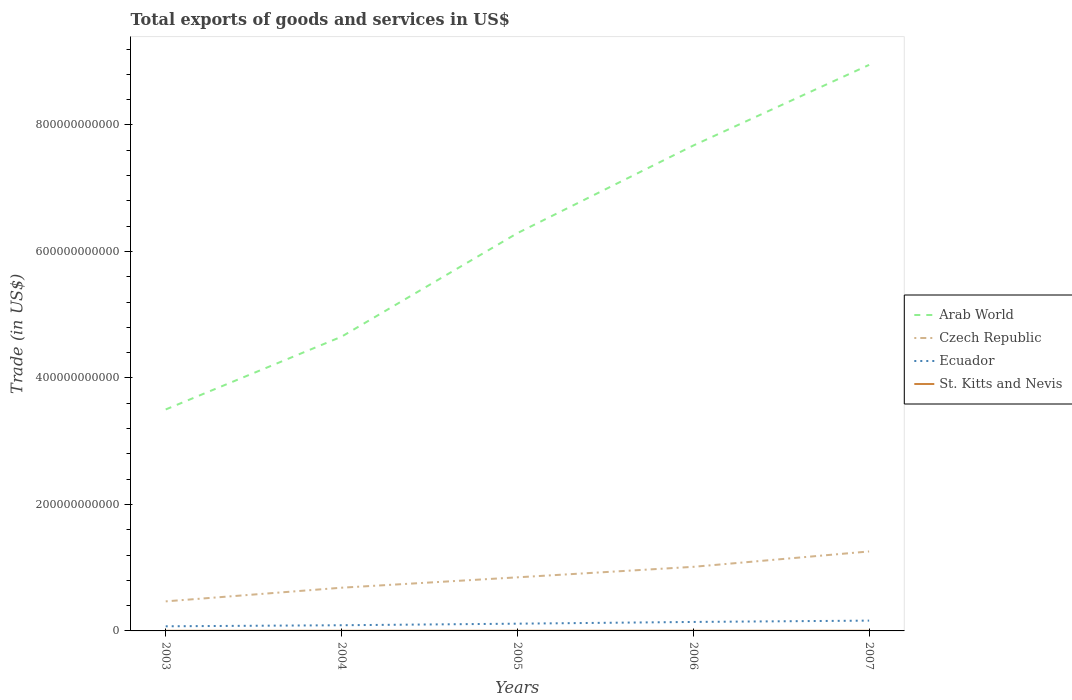Is the number of lines equal to the number of legend labels?
Ensure brevity in your answer.  Yes. Across all years, what is the maximum total exports of goods and services in Arab World?
Your answer should be very brief. 3.50e+11. What is the total total exports of goods and services in Arab World in the graph?
Offer a very short reply. -1.64e+11. What is the difference between the highest and the second highest total exports of goods and services in Ecuador?
Make the answer very short. 8.96e+09. How many lines are there?
Give a very brief answer. 4. How many years are there in the graph?
Your answer should be compact. 5. What is the difference between two consecutive major ticks on the Y-axis?
Your answer should be compact. 2.00e+11. Does the graph contain any zero values?
Your answer should be compact. No. Does the graph contain grids?
Your answer should be compact. No. Where does the legend appear in the graph?
Provide a short and direct response. Center right. What is the title of the graph?
Your answer should be compact. Total exports of goods and services in US$. What is the label or title of the Y-axis?
Give a very brief answer. Trade (in US$). What is the Trade (in US$) of Arab World in 2003?
Provide a short and direct response. 3.50e+11. What is the Trade (in US$) in Czech Republic in 2003?
Offer a very short reply. 4.67e+1. What is the Trade (in US$) in Ecuador in 2003?
Your response must be concise. 7.33e+09. What is the Trade (in US$) of St. Kitts and Nevis in 2003?
Give a very brief answer. 1.65e+08. What is the Trade (in US$) of Arab World in 2004?
Offer a very short reply. 4.65e+11. What is the Trade (in US$) in Czech Republic in 2004?
Give a very brief answer. 6.83e+1. What is the Trade (in US$) of Ecuador in 2004?
Offer a terse response. 8.98e+09. What is the Trade (in US$) of St. Kitts and Nevis in 2004?
Your answer should be very brief. 1.94e+08. What is the Trade (in US$) in Arab World in 2005?
Your answer should be compact. 6.29e+11. What is the Trade (in US$) of Czech Republic in 2005?
Your response must be concise. 8.47e+1. What is the Trade (in US$) of Ecuador in 2005?
Your response must be concise. 1.15e+1. What is the Trade (in US$) in St. Kitts and Nevis in 2005?
Your answer should be very brief. 2.27e+08. What is the Trade (in US$) in Arab World in 2006?
Give a very brief answer. 7.67e+11. What is the Trade (in US$) of Czech Republic in 2006?
Offer a very short reply. 1.01e+11. What is the Trade (in US$) of Ecuador in 2006?
Keep it short and to the point. 1.42e+1. What is the Trade (in US$) of St. Kitts and Nevis in 2006?
Keep it short and to the point. 2.36e+08. What is the Trade (in US$) of Arab World in 2007?
Make the answer very short. 8.95e+11. What is the Trade (in US$) of Czech Republic in 2007?
Keep it short and to the point. 1.26e+11. What is the Trade (in US$) of Ecuador in 2007?
Offer a very short reply. 1.63e+1. What is the Trade (in US$) in St. Kitts and Nevis in 2007?
Ensure brevity in your answer.  2.33e+08. Across all years, what is the maximum Trade (in US$) of Arab World?
Provide a short and direct response. 8.95e+11. Across all years, what is the maximum Trade (in US$) of Czech Republic?
Give a very brief answer. 1.26e+11. Across all years, what is the maximum Trade (in US$) of Ecuador?
Make the answer very short. 1.63e+1. Across all years, what is the maximum Trade (in US$) in St. Kitts and Nevis?
Offer a terse response. 2.36e+08. Across all years, what is the minimum Trade (in US$) of Arab World?
Make the answer very short. 3.50e+11. Across all years, what is the minimum Trade (in US$) of Czech Republic?
Offer a very short reply. 4.67e+1. Across all years, what is the minimum Trade (in US$) in Ecuador?
Offer a very short reply. 7.33e+09. Across all years, what is the minimum Trade (in US$) of St. Kitts and Nevis?
Your response must be concise. 1.65e+08. What is the total Trade (in US$) in Arab World in the graph?
Offer a terse response. 3.11e+12. What is the total Trade (in US$) in Czech Republic in the graph?
Provide a succinct answer. 4.27e+11. What is the total Trade (in US$) of Ecuador in the graph?
Make the answer very short. 5.83e+1. What is the total Trade (in US$) in St. Kitts and Nevis in the graph?
Offer a very short reply. 1.05e+09. What is the difference between the Trade (in US$) in Arab World in 2003 and that in 2004?
Provide a short and direct response. -1.15e+11. What is the difference between the Trade (in US$) of Czech Republic in 2003 and that in 2004?
Ensure brevity in your answer.  -2.16e+1. What is the difference between the Trade (in US$) in Ecuador in 2003 and that in 2004?
Give a very brief answer. -1.66e+09. What is the difference between the Trade (in US$) of St. Kitts and Nevis in 2003 and that in 2004?
Offer a terse response. -2.86e+07. What is the difference between the Trade (in US$) in Arab World in 2003 and that in 2005?
Keep it short and to the point. -2.79e+11. What is the difference between the Trade (in US$) in Czech Republic in 2003 and that in 2005?
Provide a short and direct response. -3.80e+1. What is the difference between the Trade (in US$) of Ecuador in 2003 and that in 2005?
Ensure brevity in your answer.  -4.13e+09. What is the difference between the Trade (in US$) of St. Kitts and Nevis in 2003 and that in 2005?
Your answer should be very brief. -6.13e+07. What is the difference between the Trade (in US$) in Arab World in 2003 and that in 2006?
Provide a succinct answer. -4.17e+11. What is the difference between the Trade (in US$) of Czech Republic in 2003 and that in 2006?
Ensure brevity in your answer.  -5.46e+1. What is the difference between the Trade (in US$) of Ecuador in 2003 and that in 2006?
Your answer should be compact. -6.87e+09. What is the difference between the Trade (in US$) in St. Kitts and Nevis in 2003 and that in 2006?
Offer a terse response. -7.04e+07. What is the difference between the Trade (in US$) of Arab World in 2003 and that in 2007?
Ensure brevity in your answer.  -5.45e+11. What is the difference between the Trade (in US$) of Czech Republic in 2003 and that in 2007?
Make the answer very short. -7.89e+1. What is the difference between the Trade (in US$) in Ecuador in 2003 and that in 2007?
Give a very brief answer. -8.96e+09. What is the difference between the Trade (in US$) of St. Kitts and Nevis in 2003 and that in 2007?
Offer a very short reply. -6.77e+07. What is the difference between the Trade (in US$) in Arab World in 2004 and that in 2005?
Provide a succinct answer. -1.64e+11. What is the difference between the Trade (in US$) of Czech Republic in 2004 and that in 2005?
Provide a succinct answer. -1.64e+1. What is the difference between the Trade (in US$) in Ecuador in 2004 and that in 2005?
Offer a terse response. -2.48e+09. What is the difference between the Trade (in US$) in St. Kitts and Nevis in 2004 and that in 2005?
Offer a terse response. -3.27e+07. What is the difference between the Trade (in US$) of Arab World in 2004 and that in 2006?
Provide a short and direct response. -3.02e+11. What is the difference between the Trade (in US$) in Czech Republic in 2004 and that in 2006?
Provide a succinct answer. -3.30e+1. What is the difference between the Trade (in US$) of Ecuador in 2004 and that in 2006?
Ensure brevity in your answer.  -5.21e+09. What is the difference between the Trade (in US$) in St. Kitts and Nevis in 2004 and that in 2006?
Provide a short and direct response. -4.18e+07. What is the difference between the Trade (in US$) of Arab World in 2004 and that in 2007?
Give a very brief answer. -4.30e+11. What is the difference between the Trade (in US$) in Czech Republic in 2004 and that in 2007?
Your response must be concise. -5.73e+1. What is the difference between the Trade (in US$) of Ecuador in 2004 and that in 2007?
Offer a terse response. -7.30e+09. What is the difference between the Trade (in US$) of St. Kitts and Nevis in 2004 and that in 2007?
Give a very brief answer. -3.91e+07. What is the difference between the Trade (in US$) in Arab World in 2005 and that in 2006?
Give a very brief answer. -1.39e+11. What is the difference between the Trade (in US$) of Czech Republic in 2005 and that in 2006?
Offer a terse response. -1.66e+1. What is the difference between the Trade (in US$) of Ecuador in 2005 and that in 2006?
Provide a short and direct response. -2.73e+09. What is the difference between the Trade (in US$) of St. Kitts and Nevis in 2005 and that in 2006?
Your response must be concise. -9.05e+06. What is the difference between the Trade (in US$) of Arab World in 2005 and that in 2007?
Offer a very short reply. -2.66e+11. What is the difference between the Trade (in US$) in Czech Republic in 2005 and that in 2007?
Provide a succinct answer. -4.09e+1. What is the difference between the Trade (in US$) in Ecuador in 2005 and that in 2007?
Give a very brief answer. -4.82e+09. What is the difference between the Trade (in US$) of St. Kitts and Nevis in 2005 and that in 2007?
Keep it short and to the point. -6.36e+06. What is the difference between the Trade (in US$) in Arab World in 2006 and that in 2007?
Provide a short and direct response. -1.28e+11. What is the difference between the Trade (in US$) of Czech Republic in 2006 and that in 2007?
Your answer should be very brief. -2.43e+1. What is the difference between the Trade (in US$) in Ecuador in 2006 and that in 2007?
Your answer should be very brief. -2.09e+09. What is the difference between the Trade (in US$) in St. Kitts and Nevis in 2006 and that in 2007?
Make the answer very short. 2.69e+06. What is the difference between the Trade (in US$) of Arab World in 2003 and the Trade (in US$) of Czech Republic in 2004?
Make the answer very short. 2.82e+11. What is the difference between the Trade (in US$) in Arab World in 2003 and the Trade (in US$) in Ecuador in 2004?
Your answer should be very brief. 3.41e+11. What is the difference between the Trade (in US$) in Arab World in 2003 and the Trade (in US$) in St. Kitts and Nevis in 2004?
Provide a succinct answer. 3.50e+11. What is the difference between the Trade (in US$) of Czech Republic in 2003 and the Trade (in US$) of Ecuador in 2004?
Offer a very short reply. 3.77e+1. What is the difference between the Trade (in US$) in Czech Republic in 2003 and the Trade (in US$) in St. Kitts and Nevis in 2004?
Your answer should be very brief. 4.65e+1. What is the difference between the Trade (in US$) in Ecuador in 2003 and the Trade (in US$) in St. Kitts and Nevis in 2004?
Your answer should be compact. 7.14e+09. What is the difference between the Trade (in US$) of Arab World in 2003 and the Trade (in US$) of Czech Republic in 2005?
Make the answer very short. 2.65e+11. What is the difference between the Trade (in US$) of Arab World in 2003 and the Trade (in US$) of Ecuador in 2005?
Offer a very short reply. 3.39e+11. What is the difference between the Trade (in US$) of Arab World in 2003 and the Trade (in US$) of St. Kitts and Nevis in 2005?
Offer a terse response. 3.50e+11. What is the difference between the Trade (in US$) of Czech Republic in 2003 and the Trade (in US$) of Ecuador in 2005?
Give a very brief answer. 3.53e+1. What is the difference between the Trade (in US$) in Czech Republic in 2003 and the Trade (in US$) in St. Kitts and Nevis in 2005?
Offer a very short reply. 4.65e+1. What is the difference between the Trade (in US$) of Ecuador in 2003 and the Trade (in US$) of St. Kitts and Nevis in 2005?
Keep it short and to the point. 7.10e+09. What is the difference between the Trade (in US$) of Arab World in 2003 and the Trade (in US$) of Czech Republic in 2006?
Keep it short and to the point. 2.49e+11. What is the difference between the Trade (in US$) in Arab World in 2003 and the Trade (in US$) in Ecuador in 2006?
Your answer should be very brief. 3.36e+11. What is the difference between the Trade (in US$) of Arab World in 2003 and the Trade (in US$) of St. Kitts and Nevis in 2006?
Provide a succinct answer. 3.50e+11. What is the difference between the Trade (in US$) of Czech Republic in 2003 and the Trade (in US$) of Ecuador in 2006?
Provide a succinct answer. 3.25e+1. What is the difference between the Trade (in US$) of Czech Republic in 2003 and the Trade (in US$) of St. Kitts and Nevis in 2006?
Provide a short and direct response. 4.65e+1. What is the difference between the Trade (in US$) of Ecuador in 2003 and the Trade (in US$) of St. Kitts and Nevis in 2006?
Provide a succinct answer. 7.09e+09. What is the difference between the Trade (in US$) of Arab World in 2003 and the Trade (in US$) of Czech Republic in 2007?
Provide a succinct answer. 2.25e+11. What is the difference between the Trade (in US$) in Arab World in 2003 and the Trade (in US$) in Ecuador in 2007?
Ensure brevity in your answer.  3.34e+11. What is the difference between the Trade (in US$) of Arab World in 2003 and the Trade (in US$) of St. Kitts and Nevis in 2007?
Make the answer very short. 3.50e+11. What is the difference between the Trade (in US$) of Czech Republic in 2003 and the Trade (in US$) of Ecuador in 2007?
Give a very brief answer. 3.04e+1. What is the difference between the Trade (in US$) of Czech Republic in 2003 and the Trade (in US$) of St. Kitts and Nevis in 2007?
Ensure brevity in your answer.  4.65e+1. What is the difference between the Trade (in US$) in Ecuador in 2003 and the Trade (in US$) in St. Kitts and Nevis in 2007?
Offer a terse response. 7.10e+09. What is the difference between the Trade (in US$) of Arab World in 2004 and the Trade (in US$) of Czech Republic in 2005?
Your answer should be very brief. 3.81e+11. What is the difference between the Trade (in US$) in Arab World in 2004 and the Trade (in US$) in Ecuador in 2005?
Keep it short and to the point. 4.54e+11. What is the difference between the Trade (in US$) in Arab World in 2004 and the Trade (in US$) in St. Kitts and Nevis in 2005?
Keep it short and to the point. 4.65e+11. What is the difference between the Trade (in US$) in Czech Republic in 2004 and the Trade (in US$) in Ecuador in 2005?
Your answer should be very brief. 5.69e+1. What is the difference between the Trade (in US$) of Czech Republic in 2004 and the Trade (in US$) of St. Kitts and Nevis in 2005?
Offer a very short reply. 6.81e+1. What is the difference between the Trade (in US$) in Ecuador in 2004 and the Trade (in US$) in St. Kitts and Nevis in 2005?
Make the answer very short. 8.76e+09. What is the difference between the Trade (in US$) in Arab World in 2004 and the Trade (in US$) in Czech Republic in 2006?
Your answer should be compact. 3.64e+11. What is the difference between the Trade (in US$) of Arab World in 2004 and the Trade (in US$) of Ecuador in 2006?
Make the answer very short. 4.51e+11. What is the difference between the Trade (in US$) in Arab World in 2004 and the Trade (in US$) in St. Kitts and Nevis in 2006?
Offer a terse response. 4.65e+11. What is the difference between the Trade (in US$) of Czech Republic in 2004 and the Trade (in US$) of Ecuador in 2006?
Provide a succinct answer. 5.41e+1. What is the difference between the Trade (in US$) of Czech Republic in 2004 and the Trade (in US$) of St. Kitts and Nevis in 2006?
Your answer should be very brief. 6.81e+1. What is the difference between the Trade (in US$) in Ecuador in 2004 and the Trade (in US$) in St. Kitts and Nevis in 2006?
Ensure brevity in your answer.  8.75e+09. What is the difference between the Trade (in US$) in Arab World in 2004 and the Trade (in US$) in Czech Republic in 2007?
Give a very brief answer. 3.40e+11. What is the difference between the Trade (in US$) in Arab World in 2004 and the Trade (in US$) in Ecuador in 2007?
Your answer should be very brief. 4.49e+11. What is the difference between the Trade (in US$) of Arab World in 2004 and the Trade (in US$) of St. Kitts and Nevis in 2007?
Provide a succinct answer. 4.65e+11. What is the difference between the Trade (in US$) of Czech Republic in 2004 and the Trade (in US$) of Ecuador in 2007?
Offer a terse response. 5.20e+1. What is the difference between the Trade (in US$) in Czech Republic in 2004 and the Trade (in US$) in St. Kitts and Nevis in 2007?
Your response must be concise. 6.81e+1. What is the difference between the Trade (in US$) of Ecuador in 2004 and the Trade (in US$) of St. Kitts and Nevis in 2007?
Offer a terse response. 8.75e+09. What is the difference between the Trade (in US$) of Arab World in 2005 and the Trade (in US$) of Czech Republic in 2006?
Provide a short and direct response. 5.28e+11. What is the difference between the Trade (in US$) in Arab World in 2005 and the Trade (in US$) in Ecuador in 2006?
Give a very brief answer. 6.15e+11. What is the difference between the Trade (in US$) in Arab World in 2005 and the Trade (in US$) in St. Kitts and Nevis in 2006?
Offer a very short reply. 6.29e+11. What is the difference between the Trade (in US$) in Czech Republic in 2005 and the Trade (in US$) in Ecuador in 2006?
Give a very brief answer. 7.05e+1. What is the difference between the Trade (in US$) of Czech Republic in 2005 and the Trade (in US$) of St. Kitts and Nevis in 2006?
Give a very brief answer. 8.45e+1. What is the difference between the Trade (in US$) of Ecuador in 2005 and the Trade (in US$) of St. Kitts and Nevis in 2006?
Provide a succinct answer. 1.12e+1. What is the difference between the Trade (in US$) of Arab World in 2005 and the Trade (in US$) of Czech Republic in 2007?
Give a very brief answer. 5.03e+11. What is the difference between the Trade (in US$) of Arab World in 2005 and the Trade (in US$) of Ecuador in 2007?
Keep it short and to the point. 6.13e+11. What is the difference between the Trade (in US$) in Arab World in 2005 and the Trade (in US$) in St. Kitts and Nevis in 2007?
Offer a very short reply. 6.29e+11. What is the difference between the Trade (in US$) of Czech Republic in 2005 and the Trade (in US$) of Ecuador in 2007?
Your answer should be very brief. 6.85e+1. What is the difference between the Trade (in US$) of Czech Republic in 2005 and the Trade (in US$) of St. Kitts and Nevis in 2007?
Give a very brief answer. 8.45e+1. What is the difference between the Trade (in US$) of Ecuador in 2005 and the Trade (in US$) of St. Kitts and Nevis in 2007?
Your response must be concise. 1.12e+1. What is the difference between the Trade (in US$) in Arab World in 2006 and the Trade (in US$) in Czech Republic in 2007?
Your answer should be very brief. 6.42e+11. What is the difference between the Trade (in US$) in Arab World in 2006 and the Trade (in US$) in Ecuador in 2007?
Your response must be concise. 7.51e+11. What is the difference between the Trade (in US$) in Arab World in 2006 and the Trade (in US$) in St. Kitts and Nevis in 2007?
Your answer should be compact. 7.67e+11. What is the difference between the Trade (in US$) in Czech Republic in 2006 and the Trade (in US$) in Ecuador in 2007?
Provide a succinct answer. 8.51e+1. What is the difference between the Trade (in US$) in Czech Republic in 2006 and the Trade (in US$) in St. Kitts and Nevis in 2007?
Provide a short and direct response. 1.01e+11. What is the difference between the Trade (in US$) in Ecuador in 2006 and the Trade (in US$) in St. Kitts and Nevis in 2007?
Your response must be concise. 1.40e+1. What is the average Trade (in US$) of Arab World per year?
Offer a terse response. 6.21e+11. What is the average Trade (in US$) of Czech Republic per year?
Give a very brief answer. 8.54e+1. What is the average Trade (in US$) in Ecuador per year?
Make the answer very short. 1.17e+1. What is the average Trade (in US$) in St. Kitts and Nevis per year?
Keep it short and to the point. 2.11e+08. In the year 2003, what is the difference between the Trade (in US$) of Arab World and Trade (in US$) of Czech Republic?
Provide a short and direct response. 3.03e+11. In the year 2003, what is the difference between the Trade (in US$) of Arab World and Trade (in US$) of Ecuador?
Make the answer very short. 3.43e+11. In the year 2003, what is the difference between the Trade (in US$) of Arab World and Trade (in US$) of St. Kitts and Nevis?
Offer a terse response. 3.50e+11. In the year 2003, what is the difference between the Trade (in US$) in Czech Republic and Trade (in US$) in Ecuador?
Your answer should be very brief. 3.94e+1. In the year 2003, what is the difference between the Trade (in US$) of Czech Republic and Trade (in US$) of St. Kitts and Nevis?
Offer a very short reply. 4.66e+1. In the year 2003, what is the difference between the Trade (in US$) of Ecuador and Trade (in US$) of St. Kitts and Nevis?
Ensure brevity in your answer.  7.16e+09. In the year 2004, what is the difference between the Trade (in US$) in Arab World and Trade (in US$) in Czech Republic?
Offer a very short reply. 3.97e+11. In the year 2004, what is the difference between the Trade (in US$) in Arab World and Trade (in US$) in Ecuador?
Your response must be concise. 4.56e+11. In the year 2004, what is the difference between the Trade (in US$) of Arab World and Trade (in US$) of St. Kitts and Nevis?
Your answer should be compact. 4.65e+11. In the year 2004, what is the difference between the Trade (in US$) of Czech Republic and Trade (in US$) of Ecuador?
Make the answer very short. 5.93e+1. In the year 2004, what is the difference between the Trade (in US$) of Czech Republic and Trade (in US$) of St. Kitts and Nevis?
Provide a succinct answer. 6.81e+1. In the year 2004, what is the difference between the Trade (in US$) in Ecuador and Trade (in US$) in St. Kitts and Nevis?
Make the answer very short. 8.79e+09. In the year 2005, what is the difference between the Trade (in US$) of Arab World and Trade (in US$) of Czech Republic?
Offer a very short reply. 5.44e+11. In the year 2005, what is the difference between the Trade (in US$) of Arab World and Trade (in US$) of Ecuador?
Offer a terse response. 6.18e+11. In the year 2005, what is the difference between the Trade (in US$) of Arab World and Trade (in US$) of St. Kitts and Nevis?
Your response must be concise. 6.29e+11. In the year 2005, what is the difference between the Trade (in US$) of Czech Republic and Trade (in US$) of Ecuador?
Your answer should be very brief. 7.33e+1. In the year 2005, what is the difference between the Trade (in US$) of Czech Republic and Trade (in US$) of St. Kitts and Nevis?
Provide a succinct answer. 8.45e+1. In the year 2005, what is the difference between the Trade (in US$) in Ecuador and Trade (in US$) in St. Kitts and Nevis?
Provide a short and direct response. 1.12e+1. In the year 2006, what is the difference between the Trade (in US$) of Arab World and Trade (in US$) of Czech Republic?
Provide a short and direct response. 6.66e+11. In the year 2006, what is the difference between the Trade (in US$) of Arab World and Trade (in US$) of Ecuador?
Give a very brief answer. 7.53e+11. In the year 2006, what is the difference between the Trade (in US$) of Arab World and Trade (in US$) of St. Kitts and Nevis?
Make the answer very short. 7.67e+11. In the year 2006, what is the difference between the Trade (in US$) of Czech Republic and Trade (in US$) of Ecuador?
Offer a terse response. 8.71e+1. In the year 2006, what is the difference between the Trade (in US$) of Czech Republic and Trade (in US$) of St. Kitts and Nevis?
Your answer should be very brief. 1.01e+11. In the year 2006, what is the difference between the Trade (in US$) of Ecuador and Trade (in US$) of St. Kitts and Nevis?
Your response must be concise. 1.40e+1. In the year 2007, what is the difference between the Trade (in US$) of Arab World and Trade (in US$) of Czech Republic?
Make the answer very short. 7.69e+11. In the year 2007, what is the difference between the Trade (in US$) in Arab World and Trade (in US$) in Ecuador?
Ensure brevity in your answer.  8.79e+11. In the year 2007, what is the difference between the Trade (in US$) of Arab World and Trade (in US$) of St. Kitts and Nevis?
Your answer should be very brief. 8.95e+11. In the year 2007, what is the difference between the Trade (in US$) of Czech Republic and Trade (in US$) of Ecuador?
Provide a short and direct response. 1.09e+11. In the year 2007, what is the difference between the Trade (in US$) of Czech Republic and Trade (in US$) of St. Kitts and Nevis?
Your answer should be very brief. 1.25e+11. In the year 2007, what is the difference between the Trade (in US$) of Ecuador and Trade (in US$) of St. Kitts and Nevis?
Keep it short and to the point. 1.61e+1. What is the ratio of the Trade (in US$) of Arab World in 2003 to that in 2004?
Keep it short and to the point. 0.75. What is the ratio of the Trade (in US$) in Czech Republic in 2003 to that in 2004?
Your response must be concise. 0.68. What is the ratio of the Trade (in US$) in Ecuador in 2003 to that in 2004?
Provide a succinct answer. 0.82. What is the ratio of the Trade (in US$) in St. Kitts and Nevis in 2003 to that in 2004?
Ensure brevity in your answer.  0.85. What is the ratio of the Trade (in US$) of Arab World in 2003 to that in 2005?
Give a very brief answer. 0.56. What is the ratio of the Trade (in US$) of Czech Republic in 2003 to that in 2005?
Provide a short and direct response. 0.55. What is the ratio of the Trade (in US$) in Ecuador in 2003 to that in 2005?
Make the answer very short. 0.64. What is the ratio of the Trade (in US$) of St. Kitts and Nevis in 2003 to that in 2005?
Keep it short and to the point. 0.73. What is the ratio of the Trade (in US$) of Arab World in 2003 to that in 2006?
Make the answer very short. 0.46. What is the ratio of the Trade (in US$) in Czech Republic in 2003 to that in 2006?
Your response must be concise. 0.46. What is the ratio of the Trade (in US$) of Ecuador in 2003 to that in 2006?
Your answer should be compact. 0.52. What is the ratio of the Trade (in US$) of St. Kitts and Nevis in 2003 to that in 2006?
Provide a succinct answer. 0.7. What is the ratio of the Trade (in US$) in Arab World in 2003 to that in 2007?
Keep it short and to the point. 0.39. What is the ratio of the Trade (in US$) in Czech Republic in 2003 to that in 2007?
Offer a terse response. 0.37. What is the ratio of the Trade (in US$) of Ecuador in 2003 to that in 2007?
Offer a very short reply. 0.45. What is the ratio of the Trade (in US$) in St. Kitts and Nevis in 2003 to that in 2007?
Offer a very short reply. 0.71. What is the ratio of the Trade (in US$) of Arab World in 2004 to that in 2005?
Your response must be concise. 0.74. What is the ratio of the Trade (in US$) in Czech Republic in 2004 to that in 2005?
Give a very brief answer. 0.81. What is the ratio of the Trade (in US$) in Ecuador in 2004 to that in 2005?
Give a very brief answer. 0.78. What is the ratio of the Trade (in US$) of St. Kitts and Nevis in 2004 to that in 2005?
Provide a short and direct response. 0.86. What is the ratio of the Trade (in US$) in Arab World in 2004 to that in 2006?
Keep it short and to the point. 0.61. What is the ratio of the Trade (in US$) in Czech Republic in 2004 to that in 2006?
Make the answer very short. 0.67. What is the ratio of the Trade (in US$) in Ecuador in 2004 to that in 2006?
Make the answer very short. 0.63. What is the ratio of the Trade (in US$) of St. Kitts and Nevis in 2004 to that in 2006?
Your response must be concise. 0.82. What is the ratio of the Trade (in US$) of Arab World in 2004 to that in 2007?
Provide a short and direct response. 0.52. What is the ratio of the Trade (in US$) of Czech Republic in 2004 to that in 2007?
Ensure brevity in your answer.  0.54. What is the ratio of the Trade (in US$) in Ecuador in 2004 to that in 2007?
Offer a very short reply. 0.55. What is the ratio of the Trade (in US$) in St. Kitts and Nevis in 2004 to that in 2007?
Offer a terse response. 0.83. What is the ratio of the Trade (in US$) of Arab World in 2005 to that in 2006?
Your answer should be compact. 0.82. What is the ratio of the Trade (in US$) in Czech Republic in 2005 to that in 2006?
Your response must be concise. 0.84. What is the ratio of the Trade (in US$) of Ecuador in 2005 to that in 2006?
Offer a very short reply. 0.81. What is the ratio of the Trade (in US$) in St. Kitts and Nevis in 2005 to that in 2006?
Make the answer very short. 0.96. What is the ratio of the Trade (in US$) of Arab World in 2005 to that in 2007?
Give a very brief answer. 0.7. What is the ratio of the Trade (in US$) in Czech Republic in 2005 to that in 2007?
Provide a succinct answer. 0.67. What is the ratio of the Trade (in US$) in Ecuador in 2005 to that in 2007?
Provide a succinct answer. 0.7. What is the ratio of the Trade (in US$) of St. Kitts and Nevis in 2005 to that in 2007?
Offer a very short reply. 0.97. What is the ratio of the Trade (in US$) in Arab World in 2006 to that in 2007?
Make the answer very short. 0.86. What is the ratio of the Trade (in US$) of Czech Republic in 2006 to that in 2007?
Make the answer very short. 0.81. What is the ratio of the Trade (in US$) of Ecuador in 2006 to that in 2007?
Your answer should be very brief. 0.87. What is the ratio of the Trade (in US$) of St. Kitts and Nevis in 2006 to that in 2007?
Offer a very short reply. 1.01. What is the difference between the highest and the second highest Trade (in US$) in Arab World?
Provide a short and direct response. 1.28e+11. What is the difference between the highest and the second highest Trade (in US$) of Czech Republic?
Provide a short and direct response. 2.43e+1. What is the difference between the highest and the second highest Trade (in US$) of Ecuador?
Provide a succinct answer. 2.09e+09. What is the difference between the highest and the second highest Trade (in US$) of St. Kitts and Nevis?
Offer a terse response. 2.69e+06. What is the difference between the highest and the lowest Trade (in US$) of Arab World?
Make the answer very short. 5.45e+11. What is the difference between the highest and the lowest Trade (in US$) in Czech Republic?
Provide a succinct answer. 7.89e+1. What is the difference between the highest and the lowest Trade (in US$) in Ecuador?
Give a very brief answer. 8.96e+09. What is the difference between the highest and the lowest Trade (in US$) of St. Kitts and Nevis?
Your answer should be very brief. 7.04e+07. 